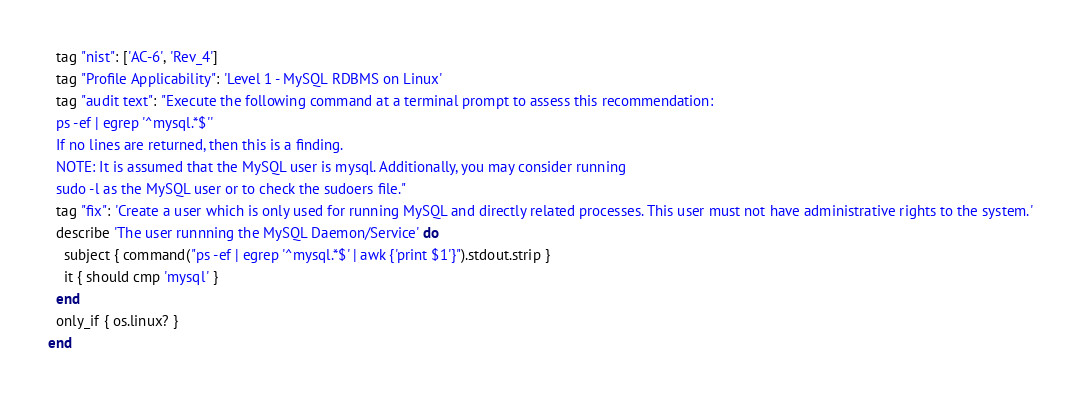Convert code to text. <code><loc_0><loc_0><loc_500><loc_500><_Ruby_>  tag "nist": ['AC-6', 'Rev_4']
  tag "Profile Applicability": 'Level 1 - MySQL RDBMS on Linux'
  tag "audit text": "Execute the following command at a terminal prompt to assess this recommendation:
  ps -ef | egrep '^mysql.*$''
  If no lines are returned, then this is a finding.
  NOTE: It is assumed that the MySQL user is mysql. Additionally, you may consider running
  sudo -l as the MySQL user or to check the sudoers file."
  tag "fix": 'Create a user which is only used for running MySQL and directly related processes. This user must not have administrative rights to the system.'
  describe 'The user runnning the MySQL Daemon/Service' do
    subject { command("ps -ef | egrep '^mysql.*$' | awk {'print $1'}").stdout.strip }
    it { should cmp 'mysql' }
  end
  only_if { os.linux? }
end
</code> 